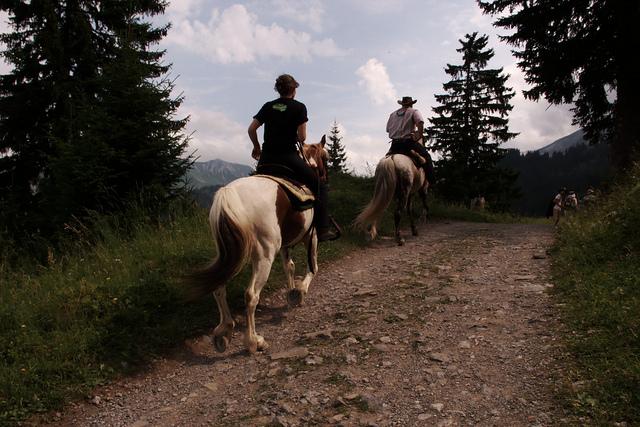What kind of a ride is this?
Answer briefly. Horse. What color shirt does the man have on?
Answer briefly. Black. What number is on the horse?
Short answer required. No number. Is this horse galloping?
Quick response, please. Yes. What is on the ground?
Give a very brief answer. Rocks. Could this animal be domesticated?
Short answer required. Yes. What color is the horse?
Give a very brief answer. White. Is the man wearing a helmet?
Answer briefly. No. How many people are in this picture?
Be succinct. 5. Could she be barrel racing?
Answer briefly. No. How many horses are there?
Keep it brief. 2. Which horse has more experience?
Answer briefly. Front. Is anyone riding the horse?
Keep it brief. Yes. What is the job of the man on the horse?
Keep it brief. Rider. Is there anyone here?
Be succinct. Yes. What is he doing to the horse?
Be succinct. Riding. What animal is this?
Concise answer only. Horse. What are the animals standing on?
Answer briefly. Ground. Is the horse wearing a saddle?
Be succinct. Yes. Does this look like a recent photograph?
Give a very brief answer. Yes. What kind of animals?
Write a very short answer. Horses. What color is the t-shirt?
Give a very brief answer. Black. Is the horse brown?
Short answer required. No. Which horse is more likely to stumble?
Write a very short answer. Rear. Are these wild horses?
Concise answer only. No. What color are the horses?
Write a very short answer. White. Are there mountains in the background?
Short answer required. Yes. What animal is the male holding?
Quick response, please. Horse. Is it sunny?
Concise answer only. Yes. Is the ground muddy?
Give a very brief answer. No. 